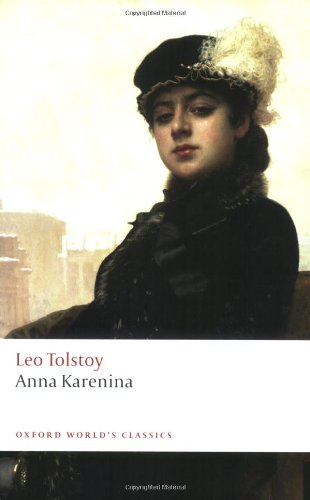What is the title of this book? The title of the book shown in the image is 'Anna Karenina'. This edition is part of the Oxford World's Classics series, well-known for its scholarly accurate and comprehensive books. 